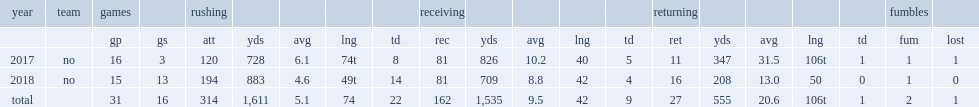How many rushing touchdowns did alvin kamara finish his second season with? 14.0. In 2017, how many rushing yards did alvin kamara finish with? 728.0. 